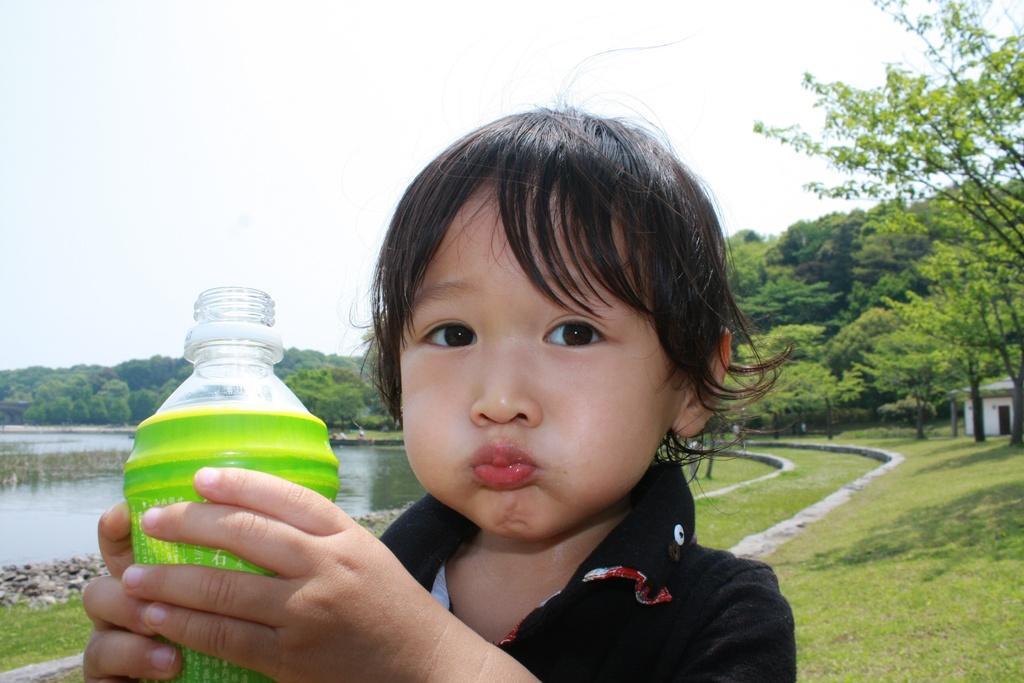Could you give a brief overview of what you see in this image? In this image i can see a child is holding a bottle in his hands. I can also see there are few trees and water. 